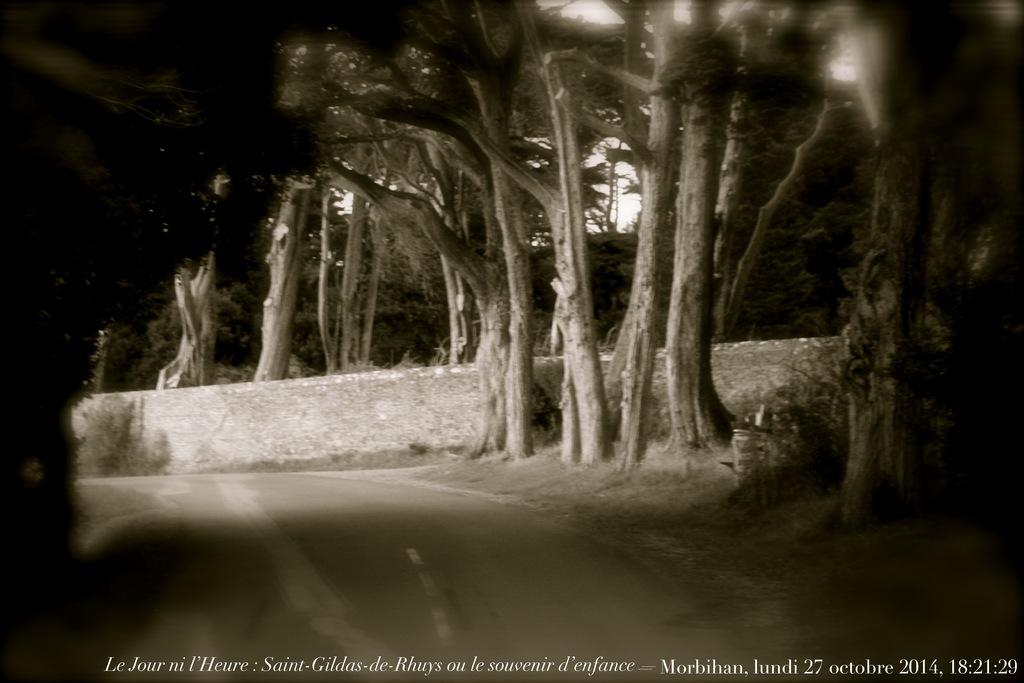What is the main feature of the image? There is a road in the image. What can be seen alongside the road? There are trees beside the road in the image. Is there any text or signage visible in the image? Yes, there is a poster with text in the image. Can you see any popcorn being sold near the river in the image? There is no river or popcorn present in the image. What type of wash is being advertised on the poster in the image? The image does not show any advertisement for a wash; it only features a poster with text. 